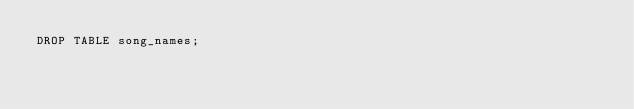<code> <loc_0><loc_0><loc_500><loc_500><_SQL_>DROP TABLE song_names;
</code> 